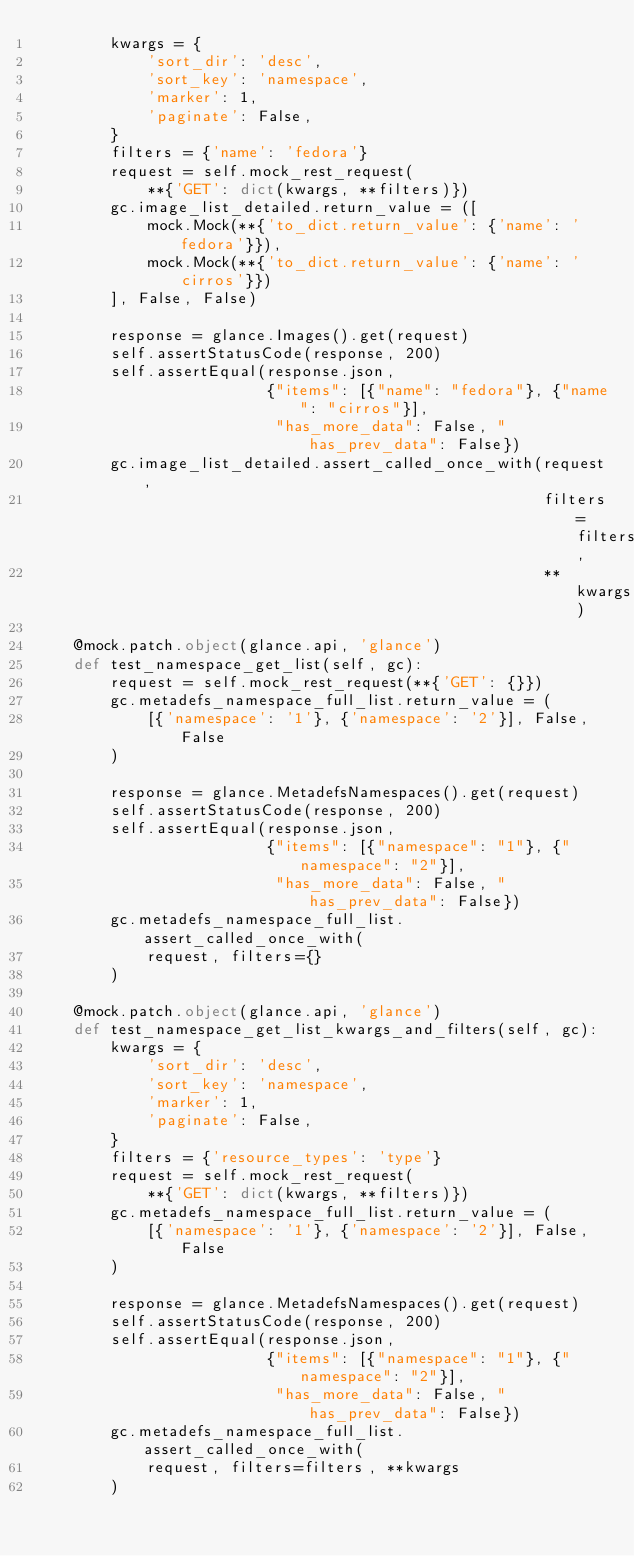<code> <loc_0><loc_0><loc_500><loc_500><_Python_>        kwargs = {
            'sort_dir': 'desc',
            'sort_key': 'namespace',
            'marker': 1,
            'paginate': False,
        }
        filters = {'name': 'fedora'}
        request = self.mock_rest_request(
            **{'GET': dict(kwargs, **filters)})
        gc.image_list_detailed.return_value = ([
            mock.Mock(**{'to_dict.return_value': {'name': 'fedora'}}),
            mock.Mock(**{'to_dict.return_value': {'name': 'cirros'}})
        ], False, False)

        response = glance.Images().get(request)
        self.assertStatusCode(response, 200)
        self.assertEqual(response.json,
                         {"items": [{"name": "fedora"}, {"name": "cirros"}],
                          "has_more_data": False, "has_prev_data": False})
        gc.image_list_detailed.assert_called_once_with(request,
                                                       filters=filters,
                                                       **kwargs)

    @mock.patch.object(glance.api, 'glance')
    def test_namespace_get_list(self, gc):
        request = self.mock_rest_request(**{'GET': {}})
        gc.metadefs_namespace_full_list.return_value = (
            [{'namespace': '1'}, {'namespace': '2'}], False, False
        )

        response = glance.MetadefsNamespaces().get(request)
        self.assertStatusCode(response, 200)
        self.assertEqual(response.json,
                         {"items": [{"namespace": "1"}, {"namespace": "2"}],
                          "has_more_data": False, "has_prev_data": False})
        gc.metadefs_namespace_full_list.assert_called_once_with(
            request, filters={}
        )

    @mock.patch.object(glance.api, 'glance')
    def test_namespace_get_list_kwargs_and_filters(self, gc):
        kwargs = {
            'sort_dir': 'desc',
            'sort_key': 'namespace',
            'marker': 1,
            'paginate': False,
        }
        filters = {'resource_types': 'type'}
        request = self.mock_rest_request(
            **{'GET': dict(kwargs, **filters)})
        gc.metadefs_namespace_full_list.return_value = (
            [{'namespace': '1'}, {'namespace': '2'}], False, False
        )

        response = glance.MetadefsNamespaces().get(request)
        self.assertStatusCode(response, 200)
        self.assertEqual(response.json,
                         {"items": [{"namespace": "1"}, {"namespace": "2"}],
                          "has_more_data": False, "has_prev_data": False})
        gc.metadefs_namespace_full_list.assert_called_once_with(
            request, filters=filters, **kwargs
        )
</code> 